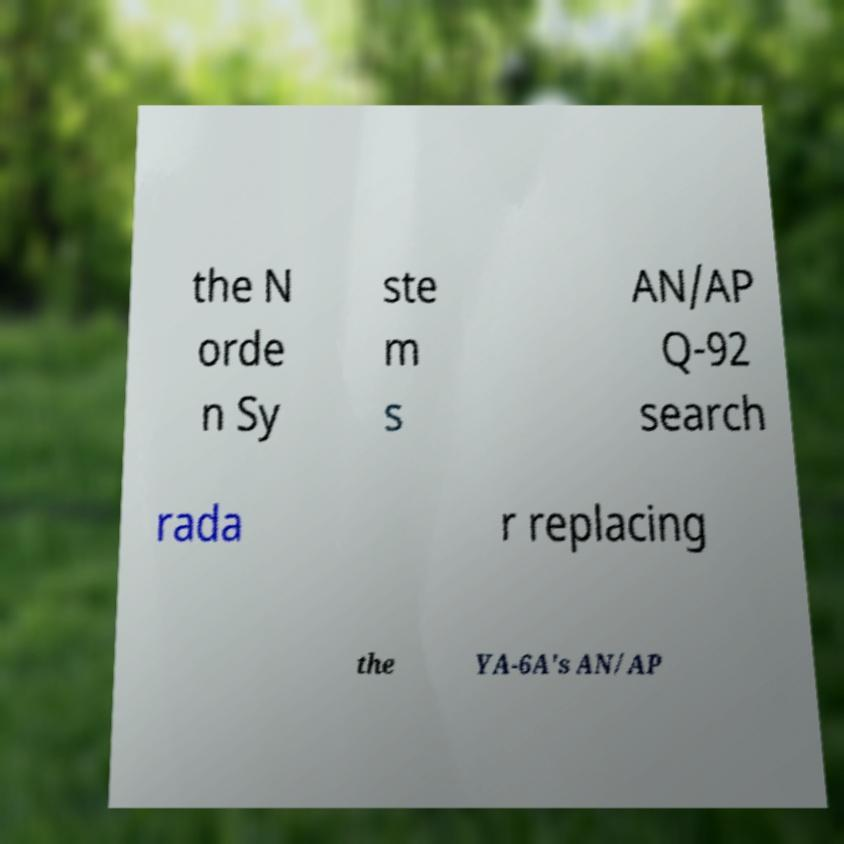Please read and relay the text visible in this image. What does it say? the N orde n Sy ste m s AN/AP Q-92 search rada r replacing the YA-6A's AN/AP 